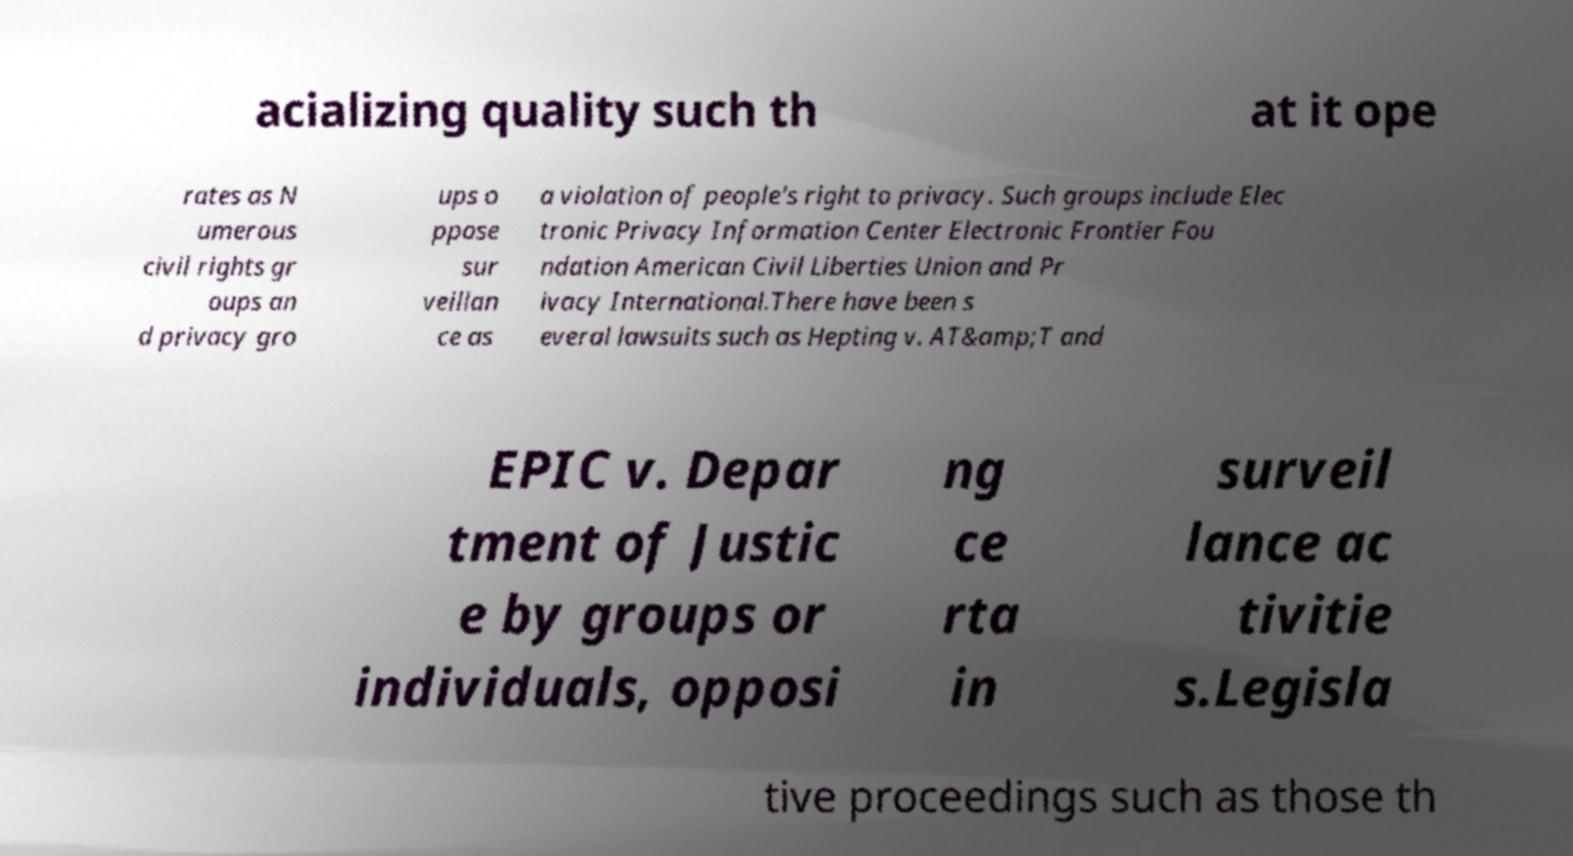Could you extract and type out the text from this image? acializing quality such th at it ope rates as N umerous civil rights gr oups an d privacy gro ups o ppose sur veillan ce as a violation of people's right to privacy. Such groups include Elec tronic Privacy Information Center Electronic Frontier Fou ndation American Civil Liberties Union and Pr ivacy International.There have been s everal lawsuits such as Hepting v. AT&amp;T and EPIC v. Depar tment of Justic e by groups or individuals, opposi ng ce rta in surveil lance ac tivitie s.Legisla tive proceedings such as those th 